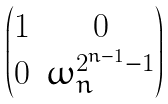Convert formula to latex. <formula><loc_0><loc_0><loc_500><loc_500>\begin{pmatrix} 1 & 0 \\ 0 & \omega ^ { 2 ^ { n - 1 } - 1 } _ { n } \end{pmatrix}</formula> 